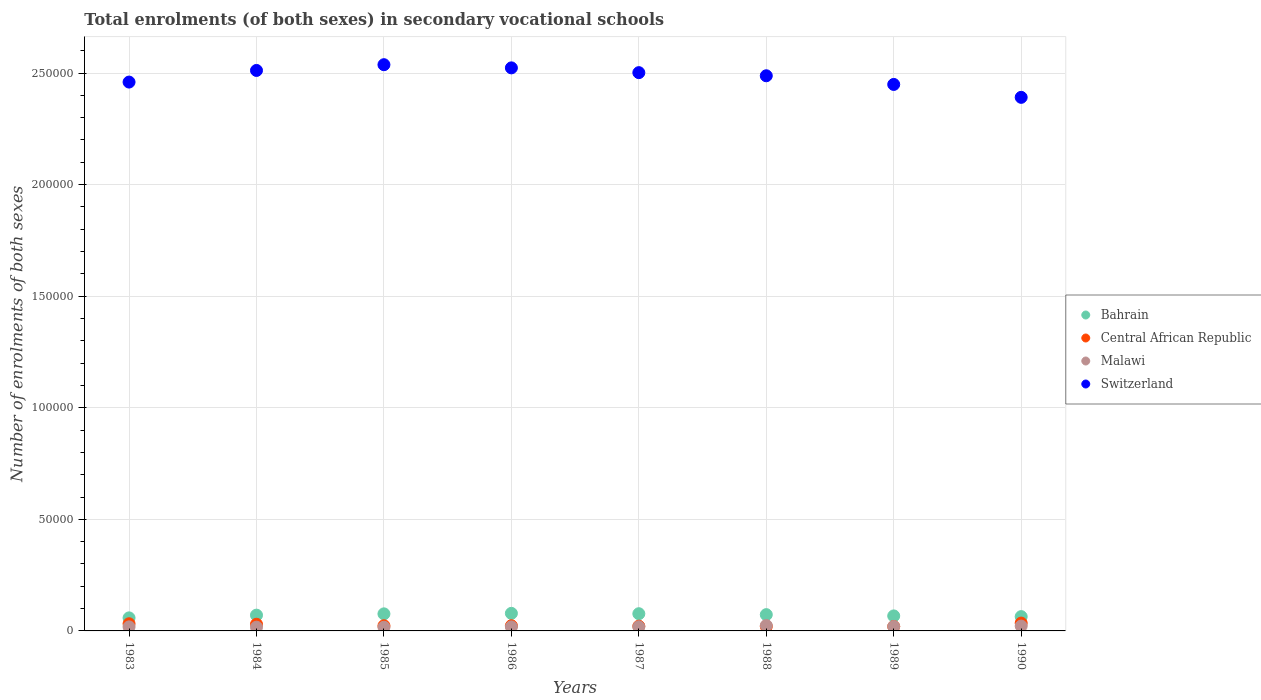How many different coloured dotlines are there?
Offer a very short reply. 4. What is the number of enrolments in secondary schools in Central African Republic in 1990?
Ensure brevity in your answer.  3514. Across all years, what is the maximum number of enrolments in secondary schools in Malawi?
Ensure brevity in your answer.  2427. Across all years, what is the minimum number of enrolments in secondary schools in Malawi?
Offer a terse response. 1669. In which year was the number of enrolments in secondary schools in Central African Republic maximum?
Keep it short and to the point. 1990. What is the total number of enrolments in secondary schools in Switzerland in the graph?
Keep it short and to the point. 1.99e+06. What is the difference between the number of enrolments in secondary schools in Bahrain in 1986 and that in 1987?
Your answer should be compact. 160. What is the difference between the number of enrolments in secondary schools in Bahrain in 1989 and the number of enrolments in secondary schools in Switzerland in 1983?
Offer a very short reply. -2.39e+05. What is the average number of enrolments in secondary schools in Central African Republic per year?
Your answer should be very brief. 2562.25. In the year 1985, what is the difference between the number of enrolments in secondary schools in Central African Republic and number of enrolments in secondary schools in Malawi?
Your answer should be very brief. 648. What is the ratio of the number of enrolments in secondary schools in Bahrain in 1984 to that in 1986?
Give a very brief answer. 0.9. Is the difference between the number of enrolments in secondary schools in Central African Republic in 1987 and 1989 greater than the difference between the number of enrolments in secondary schools in Malawi in 1987 and 1989?
Offer a terse response. Yes. What is the difference between the highest and the second highest number of enrolments in secondary schools in Malawi?
Give a very brief answer. 251. What is the difference between the highest and the lowest number of enrolments in secondary schools in Malawi?
Your answer should be very brief. 758. Is it the case that in every year, the sum of the number of enrolments in secondary schools in Central African Republic and number of enrolments in secondary schools in Switzerland  is greater than the sum of number of enrolments in secondary schools in Malawi and number of enrolments in secondary schools in Bahrain?
Ensure brevity in your answer.  Yes. Is it the case that in every year, the sum of the number of enrolments in secondary schools in Switzerland and number of enrolments in secondary schools in Central African Republic  is greater than the number of enrolments in secondary schools in Bahrain?
Your answer should be compact. Yes. Is the number of enrolments in secondary schools in Bahrain strictly greater than the number of enrolments in secondary schools in Malawi over the years?
Provide a succinct answer. Yes. Is the number of enrolments in secondary schools in Bahrain strictly less than the number of enrolments in secondary schools in Malawi over the years?
Offer a terse response. No. What is the difference between two consecutive major ticks on the Y-axis?
Your response must be concise. 5.00e+04. Are the values on the major ticks of Y-axis written in scientific E-notation?
Keep it short and to the point. No. What is the title of the graph?
Keep it short and to the point. Total enrolments (of both sexes) in secondary vocational schools. What is the label or title of the Y-axis?
Your answer should be compact. Number of enrolments of both sexes. What is the Number of enrolments of both sexes in Bahrain in 1983?
Ensure brevity in your answer.  5844. What is the Number of enrolments of both sexes in Central African Republic in 1983?
Ensure brevity in your answer.  3213. What is the Number of enrolments of both sexes of Malawi in 1983?
Offer a very short reply. 1814. What is the Number of enrolments of both sexes in Switzerland in 1983?
Provide a succinct answer. 2.46e+05. What is the Number of enrolments of both sexes of Bahrain in 1984?
Your answer should be very brief. 7067. What is the Number of enrolments of both sexes in Central African Republic in 1984?
Your response must be concise. 2993. What is the Number of enrolments of both sexes of Malawi in 1984?
Your response must be concise. 1688. What is the Number of enrolments of both sexes in Switzerland in 1984?
Ensure brevity in your answer.  2.51e+05. What is the Number of enrolments of both sexes in Bahrain in 1985?
Keep it short and to the point. 7648. What is the Number of enrolments of both sexes of Central African Republic in 1985?
Provide a succinct answer. 2317. What is the Number of enrolments of both sexes in Malawi in 1985?
Your answer should be very brief. 1669. What is the Number of enrolments of both sexes in Switzerland in 1985?
Give a very brief answer. 2.54e+05. What is the Number of enrolments of both sexes in Bahrain in 1986?
Ensure brevity in your answer.  7870. What is the Number of enrolments of both sexes in Central African Republic in 1986?
Offer a terse response. 2332. What is the Number of enrolments of both sexes of Malawi in 1986?
Your response must be concise. 1818. What is the Number of enrolments of both sexes in Switzerland in 1986?
Your answer should be very brief. 2.52e+05. What is the Number of enrolments of both sexes of Bahrain in 1987?
Offer a very short reply. 7710. What is the Number of enrolments of both sexes in Central African Republic in 1987?
Offer a very short reply. 2132. What is the Number of enrolments of both sexes in Malawi in 1987?
Your answer should be compact. 1860. What is the Number of enrolments of both sexes in Switzerland in 1987?
Offer a very short reply. 2.50e+05. What is the Number of enrolments of both sexes of Bahrain in 1988?
Offer a terse response. 7294. What is the Number of enrolments of both sexes of Central African Republic in 1988?
Give a very brief answer. 2008. What is the Number of enrolments of both sexes in Malawi in 1988?
Provide a succinct answer. 2427. What is the Number of enrolments of both sexes in Switzerland in 1988?
Your response must be concise. 2.49e+05. What is the Number of enrolments of both sexes of Bahrain in 1989?
Your answer should be compact. 6725. What is the Number of enrolments of both sexes in Central African Republic in 1989?
Keep it short and to the point. 1989. What is the Number of enrolments of both sexes of Malawi in 1989?
Your response must be concise. 1984. What is the Number of enrolments of both sexes in Switzerland in 1989?
Offer a very short reply. 2.45e+05. What is the Number of enrolments of both sexes of Bahrain in 1990?
Your response must be concise. 6412. What is the Number of enrolments of both sexes of Central African Republic in 1990?
Your response must be concise. 3514. What is the Number of enrolments of both sexes of Malawi in 1990?
Your response must be concise. 2176. What is the Number of enrolments of both sexes of Switzerland in 1990?
Provide a succinct answer. 2.39e+05. Across all years, what is the maximum Number of enrolments of both sexes of Bahrain?
Offer a terse response. 7870. Across all years, what is the maximum Number of enrolments of both sexes of Central African Republic?
Offer a terse response. 3514. Across all years, what is the maximum Number of enrolments of both sexes in Malawi?
Your response must be concise. 2427. Across all years, what is the maximum Number of enrolments of both sexes of Switzerland?
Provide a succinct answer. 2.54e+05. Across all years, what is the minimum Number of enrolments of both sexes of Bahrain?
Your answer should be compact. 5844. Across all years, what is the minimum Number of enrolments of both sexes in Central African Republic?
Your answer should be compact. 1989. Across all years, what is the minimum Number of enrolments of both sexes in Malawi?
Your response must be concise. 1669. Across all years, what is the minimum Number of enrolments of both sexes in Switzerland?
Offer a very short reply. 2.39e+05. What is the total Number of enrolments of both sexes of Bahrain in the graph?
Offer a terse response. 5.66e+04. What is the total Number of enrolments of both sexes in Central African Republic in the graph?
Offer a terse response. 2.05e+04. What is the total Number of enrolments of both sexes of Malawi in the graph?
Provide a short and direct response. 1.54e+04. What is the total Number of enrolments of both sexes of Switzerland in the graph?
Offer a very short reply. 1.99e+06. What is the difference between the Number of enrolments of both sexes in Bahrain in 1983 and that in 1984?
Keep it short and to the point. -1223. What is the difference between the Number of enrolments of both sexes of Central African Republic in 1983 and that in 1984?
Offer a very short reply. 220. What is the difference between the Number of enrolments of both sexes in Malawi in 1983 and that in 1984?
Offer a very short reply. 126. What is the difference between the Number of enrolments of both sexes of Switzerland in 1983 and that in 1984?
Keep it short and to the point. -5213. What is the difference between the Number of enrolments of both sexes in Bahrain in 1983 and that in 1985?
Provide a succinct answer. -1804. What is the difference between the Number of enrolments of both sexes of Central African Republic in 1983 and that in 1985?
Make the answer very short. 896. What is the difference between the Number of enrolments of both sexes in Malawi in 1983 and that in 1985?
Provide a short and direct response. 145. What is the difference between the Number of enrolments of both sexes of Switzerland in 1983 and that in 1985?
Offer a very short reply. -7787. What is the difference between the Number of enrolments of both sexes of Bahrain in 1983 and that in 1986?
Keep it short and to the point. -2026. What is the difference between the Number of enrolments of both sexes of Central African Republic in 1983 and that in 1986?
Offer a very short reply. 881. What is the difference between the Number of enrolments of both sexes in Malawi in 1983 and that in 1986?
Make the answer very short. -4. What is the difference between the Number of enrolments of both sexes of Switzerland in 1983 and that in 1986?
Offer a very short reply. -6367. What is the difference between the Number of enrolments of both sexes in Bahrain in 1983 and that in 1987?
Ensure brevity in your answer.  -1866. What is the difference between the Number of enrolments of both sexes of Central African Republic in 1983 and that in 1987?
Give a very brief answer. 1081. What is the difference between the Number of enrolments of both sexes of Malawi in 1983 and that in 1987?
Keep it short and to the point. -46. What is the difference between the Number of enrolments of both sexes of Switzerland in 1983 and that in 1987?
Ensure brevity in your answer.  -4228. What is the difference between the Number of enrolments of both sexes in Bahrain in 1983 and that in 1988?
Give a very brief answer. -1450. What is the difference between the Number of enrolments of both sexes of Central African Republic in 1983 and that in 1988?
Your answer should be very brief. 1205. What is the difference between the Number of enrolments of both sexes in Malawi in 1983 and that in 1988?
Keep it short and to the point. -613. What is the difference between the Number of enrolments of both sexes of Switzerland in 1983 and that in 1988?
Offer a very short reply. -2825. What is the difference between the Number of enrolments of both sexes of Bahrain in 1983 and that in 1989?
Provide a short and direct response. -881. What is the difference between the Number of enrolments of both sexes in Central African Republic in 1983 and that in 1989?
Offer a terse response. 1224. What is the difference between the Number of enrolments of both sexes of Malawi in 1983 and that in 1989?
Make the answer very short. -170. What is the difference between the Number of enrolments of both sexes in Switzerland in 1983 and that in 1989?
Provide a short and direct response. 1058. What is the difference between the Number of enrolments of both sexes of Bahrain in 1983 and that in 1990?
Give a very brief answer. -568. What is the difference between the Number of enrolments of both sexes of Central African Republic in 1983 and that in 1990?
Provide a short and direct response. -301. What is the difference between the Number of enrolments of both sexes of Malawi in 1983 and that in 1990?
Your response must be concise. -362. What is the difference between the Number of enrolments of both sexes of Switzerland in 1983 and that in 1990?
Your answer should be compact. 6842. What is the difference between the Number of enrolments of both sexes in Bahrain in 1984 and that in 1985?
Offer a very short reply. -581. What is the difference between the Number of enrolments of both sexes of Central African Republic in 1984 and that in 1985?
Provide a short and direct response. 676. What is the difference between the Number of enrolments of both sexes in Switzerland in 1984 and that in 1985?
Make the answer very short. -2574. What is the difference between the Number of enrolments of both sexes of Bahrain in 1984 and that in 1986?
Your response must be concise. -803. What is the difference between the Number of enrolments of both sexes in Central African Republic in 1984 and that in 1986?
Provide a short and direct response. 661. What is the difference between the Number of enrolments of both sexes in Malawi in 1984 and that in 1986?
Provide a short and direct response. -130. What is the difference between the Number of enrolments of both sexes of Switzerland in 1984 and that in 1986?
Provide a short and direct response. -1154. What is the difference between the Number of enrolments of both sexes in Bahrain in 1984 and that in 1987?
Your answer should be very brief. -643. What is the difference between the Number of enrolments of both sexes of Central African Republic in 1984 and that in 1987?
Provide a short and direct response. 861. What is the difference between the Number of enrolments of both sexes in Malawi in 1984 and that in 1987?
Keep it short and to the point. -172. What is the difference between the Number of enrolments of both sexes in Switzerland in 1984 and that in 1987?
Your answer should be compact. 985. What is the difference between the Number of enrolments of both sexes of Bahrain in 1984 and that in 1988?
Give a very brief answer. -227. What is the difference between the Number of enrolments of both sexes in Central African Republic in 1984 and that in 1988?
Provide a succinct answer. 985. What is the difference between the Number of enrolments of both sexes of Malawi in 1984 and that in 1988?
Ensure brevity in your answer.  -739. What is the difference between the Number of enrolments of both sexes in Switzerland in 1984 and that in 1988?
Offer a very short reply. 2388. What is the difference between the Number of enrolments of both sexes of Bahrain in 1984 and that in 1989?
Give a very brief answer. 342. What is the difference between the Number of enrolments of both sexes in Central African Republic in 1984 and that in 1989?
Provide a short and direct response. 1004. What is the difference between the Number of enrolments of both sexes in Malawi in 1984 and that in 1989?
Your answer should be compact. -296. What is the difference between the Number of enrolments of both sexes of Switzerland in 1984 and that in 1989?
Provide a succinct answer. 6271. What is the difference between the Number of enrolments of both sexes of Bahrain in 1984 and that in 1990?
Your answer should be compact. 655. What is the difference between the Number of enrolments of both sexes of Central African Republic in 1984 and that in 1990?
Provide a short and direct response. -521. What is the difference between the Number of enrolments of both sexes in Malawi in 1984 and that in 1990?
Offer a very short reply. -488. What is the difference between the Number of enrolments of both sexes of Switzerland in 1984 and that in 1990?
Your answer should be very brief. 1.21e+04. What is the difference between the Number of enrolments of both sexes in Bahrain in 1985 and that in 1986?
Offer a very short reply. -222. What is the difference between the Number of enrolments of both sexes in Central African Republic in 1985 and that in 1986?
Your answer should be compact. -15. What is the difference between the Number of enrolments of both sexes in Malawi in 1985 and that in 1986?
Keep it short and to the point. -149. What is the difference between the Number of enrolments of both sexes in Switzerland in 1985 and that in 1986?
Keep it short and to the point. 1420. What is the difference between the Number of enrolments of both sexes of Bahrain in 1985 and that in 1987?
Your response must be concise. -62. What is the difference between the Number of enrolments of both sexes of Central African Republic in 1985 and that in 1987?
Give a very brief answer. 185. What is the difference between the Number of enrolments of both sexes in Malawi in 1985 and that in 1987?
Offer a terse response. -191. What is the difference between the Number of enrolments of both sexes in Switzerland in 1985 and that in 1987?
Make the answer very short. 3559. What is the difference between the Number of enrolments of both sexes of Bahrain in 1985 and that in 1988?
Your answer should be compact. 354. What is the difference between the Number of enrolments of both sexes in Central African Republic in 1985 and that in 1988?
Offer a terse response. 309. What is the difference between the Number of enrolments of both sexes of Malawi in 1985 and that in 1988?
Give a very brief answer. -758. What is the difference between the Number of enrolments of both sexes in Switzerland in 1985 and that in 1988?
Provide a short and direct response. 4962. What is the difference between the Number of enrolments of both sexes in Bahrain in 1985 and that in 1989?
Your answer should be compact. 923. What is the difference between the Number of enrolments of both sexes of Central African Republic in 1985 and that in 1989?
Give a very brief answer. 328. What is the difference between the Number of enrolments of both sexes of Malawi in 1985 and that in 1989?
Make the answer very short. -315. What is the difference between the Number of enrolments of both sexes of Switzerland in 1985 and that in 1989?
Ensure brevity in your answer.  8845. What is the difference between the Number of enrolments of both sexes of Bahrain in 1985 and that in 1990?
Provide a succinct answer. 1236. What is the difference between the Number of enrolments of both sexes of Central African Republic in 1985 and that in 1990?
Your response must be concise. -1197. What is the difference between the Number of enrolments of both sexes of Malawi in 1985 and that in 1990?
Your answer should be very brief. -507. What is the difference between the Number of enrolments of both sexes of Switzerland in 1985 and that in 1990?
Provide a succinct answer. 1.46e+04. What is the difference between the Number of enrolments of both sexes of Bahrain in 1986 and that in 1987?
Offer a very short reply. 160. What is the difference between the Number of enrolments of both sexes in Malawi in 1986 and that in 1987?
Provide a short and direct response. -42. What is the difference between the Number of enrolments of both sexes of Switzerland in 1986 and that in 1987?
Keep it short and to the point. 2139. What is the difference between the Number of enrolments of both sexes in Bahrain in 1986 and that in 1988?
Provide a succinct answer. 576. What is the difference between the Number of enrolments of both sexes in Central African Republic in 1986 and that in 1988?
Provide a short and direct response. 324. What is the difference between the Number of enrolments of both sexes of Malawi in 1986 and that in 1988?
Give a very brief answer. -609. What is the difference between the Number of enrolments of both sexes in Switzerland in 1986 and that in 1988?
Your answer should be very brief. 3542. What is the difference between the Number of enrolments of both sexes in Bahrain in 1986 and that in 1989?
Your answer should be compact. 1145. What is the difference between the Number of enrolments of both sexes in Central African Republic in 1986 and that in 1989?
Provide a short and direct response. 343. What is the difference between the Number of enrolments of both sexes of Malawi in 1986 and that in 1989?
Your answer should be very brief. -166. What is the difference between the Number of enrolments of both sexes in Switzerland in 1986 and that in 1989?
Make the answer very short. 7425. What is the difference between the Number of enrolments of both sexes in Bahrain in 1986 and that in 1990?
Offer a terse response. 1458. What is the difference between the Number of enrolments of both sexes of Central African Republic in 1986 and that in 1990?
Your response must be concise. -1182. What is the difference between the Number of enrolments of both sexes in Malawi in 1986 and that in 1990?
Your answer should be very brief. -358. What is the difference between the Number of enrolments of both sexes of Switzerland in 1986 and that in 1990?
Your answer should be very brief. 1.32e+04. What is the difference between the Number of enrolments of both sexes in Bahrain in 1987 and that in 1988?
Make the answer very short. 416. What is the difference between the Number of enrolments of both sexes of Central African Republic in 1987 and that in 1988?
Offer a very short reply. 124. What is the difference between the Number of enrolments of both sexes in Malawi in 1987 and that in 1988?
Give a very brief answer. -567. What is the difference between the Number of enrolments of both sexes in Switzerland in 1987 and that in 1988?
Give a very brief answer. 1403. What is the difference between the Number of enrolments of both sexes of Bahrain in 1987 and that in 1989?
Keep it short and to the point. 985. What is the difference between the Number of enrolments of both sexes of Central African Republic in 1987 and that in 1989?
Provide a succinct answer. 143. What is the difference between the Number of enrolments of both sexes in Malawi in 1987 and that in 1989?
Keep it short and to the point. -124. What is the difference between the Number of enrolments of both sexes of Switzerland in 1987 and that in 1989?
Your answer should be compact. 5286. What is the difference between the Number of enrolments of both sexes of Bahrain in 1987 and that in 1990?
Provide a short and direct response. 1298. What is the difference between the Number of enrolments of both sexes in Central African Republic in 1987 and that in 1990?
Your answer should be compact. -1382. What is the difference between the Number of enrolments of both sexes of Malawi in 1987 and that in 1990?
Give a very brief answer. -316. What is the difference between the Number of enrolments of both sexes of Switzerland in 1987 and that in 1990?
Ensure brevity in your answer.  1.11e+04. What is the difference between the Number of enrolments of both sexes in Bahrain in 1988 and that in 1989?
Keep it short and to the point. 569. What is the difference between the Number of enrolments of both sexes in Malawi in 1988 and that in 1989?
Offer a terse response. 443. What is the difference between the Number of enrolments of both sexes in Switzerland in 1988 and that in 1989?
Give a very brief answer. 3883. What is the difference between the Number of enrolments of both sexes in Bahrain in 1988 and that in 1990?
Ensure brevity in your answer.  882. What is the difference between the Number of enrolments of both sexes of Central African Republic in 1988 and that in 1990?
Give a very brief answer. -1506. What is the difference between the Number of enrolments of both sexes in Malawi in 1988 and that in 1990?
Provide a short and direct response. 251. What is the difference between the Number of enrolments of both sexes of Switzerland in 1988 and that in 1990?
Provide a succinct answer. 9667. What is the difference between the Number of enrolments of both sexes of Bahrain in 1989 and that in 1990?
Your answer should be compact. 313. What is the difference between the Number of enrolments of both sexes of Central African Republic in 1989 and that in 1990?
Your answer should be very brief. -1525. What is the difference between the Number of enrolments of both sexes in Malawi in 1989 and that in 1990?
Ensure brevity in your answer.  -192. What is the difference between the Number of enrolments of both sexes in Switzerland in 1989 and that in 1990?
Your response must be concise. 5784. What is the difference between the Number of enrolments of both sexes in Bahrain in 1983 and the Number of enrolments of both sexes in Central African Republic in 1984?
Your answer should be compact. 2851. What is the difference between the Number of enrolments of both sexes in Bahrain in 1983 and the Number of enrolments of both sexes in Malawi in 1984?
Provide a short and direct response. 4156. What is the difference between the Number of enrolments of both sexes of Bahrain in 1983 and the Number of enrolments of both sexes of Switzerland in 1984?
Keep it short and to the point. -2.45e+05. What is the difference between the Number of enrolments of both sexes in Central African Republic in 1983 and the Number of enrolments of both sexes in Malawi in 1984?
Your answer should be very brief. 1525. What is the difference between the Number of enrolments of both sexes in Central African Republic in 1983 and the Number of enrolments of both sexes in Switzerland in 1984?
Make the answer very short. -2.48e+05. What is the difference between the Number of enrolments of both sexes of Malawi in 1983 and the Number of enrolments of both sexes of Switzerland in 1984?
Your response must be concise. -2.49e+05. What is the difference between the Number of enrolments of both sexes of Bahrain in 1983 and the Number of enrolments of both sexes of Central African Republic in 1985?
Offer a terse response. 3527. What is the difference between the Number of enrolments of both sexes in Bahrain in 1983 and the Number of enrolments of both sexes in Malawi in 1985?
Provide a succinct answer. 4175. What is the difference between the Number of enrolments of both sexes in Bahrain in 1983 and the Number of enrolments of both sexes in Switzerland in 1985?
Provide a short and direct response. -2.48e+05. What is the difference between the Number of enrolments of both sexes of Central African Republic in 1983 and the Number of enrolments of both sexes of Malawi in 1985?
Offer a terse response. 1544. What is the difference between the Number of enrolments of both sexes of Central African Republic in 1983 and the Number of enrolments of both sexes of Switzerland in 1985?
Your response must be concise. -2.51e+05. What is the difference between the Number of enrolments of both sexes in Malawi in 1983 and the Number of enrolments of both sexes in Switzerland in 1985?
Provide a short and direct response. -2.52e+05. What is the difference between the Number of enrolments of both sexes in Bahrain in 1983 and the Number of enrolments of both sexes in Central African Republic in 1986?
Give a very brief answer. 3512. What is the difference between the Number of enrolments of both sexes in Bahrain in 1983 and the Number of enrolments of both sexes in Malawi in 1986?
Keep it short and to the point. 4026. What is the difference between the Number of enrolments of both sexes of Bahrain in 1983 and the Number of enrolments of both sexes of Switzerland in 1986?
Offer a terse response. -2.46e+05. What is the difference between the Number of enrolments of both sexes of Central African Republic in 1983 and the Number of enrolments of both sexes of Malawi in 1986?
Make the answer very short. 1395. What is the difference between the Number of enrolments of both sexes in Central African Republic in 1983 and the Number of enrolments of both sexes in Switzerland in 1986?
Give a very brief answer. -2.49e+05. What is the difference between the Number of enrolments of both sexes in Malawi in 1983 and the Number of enrolments of both sexes in Switzerland in 1986?
Give a very brief answer. -2.50e+05. What is the difference between the Number of enrolments of both sexes of Bahrain in 1983 and the Number of enrolments of both sexes of Central African Republic in 1987?
Provide a short and direct response. 3712. What is the difference between the Number of enrolments of both sexes in Bahrain in 1983 and the Number of enrolments of both sexes in Malawi in 1987?
Make the answer very short. 3984. What is the difference between the Number of enrolments of both sexes of Bahrain in 1983 and the Number of enrolments of both sexes of Switzerland in 1987?
Provide a short and direct response. -2.44e+05. What is the difference between the Number of enrolments of both sexes of Central African Republic in 1983 and the Number of enrolments of both sexes of Malawi in 1987?
Make the answer very short. 1353. What is the difference between the Number of enrolments of both sexes of Central African Republic in 1983 and the Number of enrolments of both sexes of Switzerland in 1987?
Keep it short and to the point. -2.47e+05. What is the difference between the Number of enrolments of both sexes in Malawi in 1983 and the Number of enrolments of both sexes in Switzerland in 1987?
Offer a terse response. -2.48e+05. What is the difference between the Number of enrolments of both sexes in Bahrain in 1983 and the Number of enrolments of both sexes in Central African Republic in 1988?
Keep it short and to the point. 3836. What is the difference between the Number of enrolments of both sexes of Bahrain in 1983 and the Number of enrolments of both sexes of Malawi in 1988?
Your response must be concise. 3417. What is the difference between the Number of enrolments of both sexes in Bahrain in 1983 and the Number of enrolments of both sexes in Switzerland in 1988?
Keep it short and to the point. -2.43e+05. What is the difference between the Number of enrolments of both sexes of Central African Republic in 1983 and the Number of enrolments of both sexes of Malawi in 1988?
Keep it short and to the point. 786. What is the difference between the Number of enrolments of both sexes of Central African Republic in 1983 and the Number of enrolments of both sexes of Switzerland in 1988?
Give a very brief answer. -2.46e+05. What is the difference between the Number of enrolments of both sexes of Malawi in 1983 and the Number of enrolments of both sexes of Switzerland in 1988?
Give a very brief answer. -2.47e+05. What is the difference between the Number of enrolments of both sexes of Bahrain in 1983 and the Number of enrolments of both sexes of Central African Republic in 1989?
Your answer should be compact. 3855. What is the difference between the Number of enrolments of both sexes in Bahrain in 1983 and the Number of enrolments of both sexes in Malawi in 1989?
Your answer should be very brief. 3860. What is the difference between the Number of enrolments of both sexes of Bahrain in 1983 and the Number of enrolments of both sexes of Switzerland in 1989?
Ensure brevity in your answer.  -2.39e+05. What is the difference between the Number of enrolments of both sexes of Central African Republic in 1983 and the Number of enrolments of both sexes of Malawi in 1989?
Offer a terse response. 1229. What is the difference between the Number of enrolments of both sexes in Central African Republic in 1983 and the Number of enrolments of both sexes in Switzerland in 1989?
Offer a terse response. -2.42e+05. What is the difference between the Number of enrolments of both sexes of Malawi in 1983 and the Number of enrolments of both sexes of Switzerland in 1989?
Provide a short and direct response. -2.43e+05. What is the difference between the Number of enrolments of both sexes in Bahrain in 1983 and the Number of enrolments of both sexes in Central African Republic in 1990?
Your response must be concise. 2330. What is the difference between the Number of enrolments of both sexes of Bahrain in 1983 and the Number of enrolments of both sexes of Malawi in 1990?
Your response must be concise. 3668. What is the difference between the Number of enrolments of both sexes in Bahrain in 1983 and the Number of enrolments of both sexes in Switzerland in 1990?
Offer a very short reply. -2.33e+05. What is the difference between the Number of enrolments of both sexes of Central African Republic in 1983 and the Number of enrolments of both sexes of Malawi in 1990?
Provide a short and direct response. 1037. What is the difference between the Number of enrolments of both sexes of Central African Republic in 1983 and the Number of enrolments of both sexes of Switzerland in 1990?
Ensure brevity in your answer.  -2.36e+05. What is the difference between the Number of enrolments of both sexes in Malawi in 1983 and the Number of enrolments of both sexes in Switzerland in 1990?
Provide a short and direct response. -2.37e+05. What is the difference between the Number of enrolments of both sexes of Bahrain in 1984 and the Number of enrolments of both sexes of Central African Republic in 1985?
Offer a terse response. 4750. What is the difference between the Number of enrolments of both sexes in Bahrain in 1984 and the Number of enrolments of both sexes in Malawi in 1985?
Ensure brevity in your answer.  5398. What is the difference between the Number of enrolments of both sexes in Bahrain in 1984 and the Number of enrolments of both sexes in Switzerland in 1985?
Offer a very short reply. -2.47e+05. What is the difference between the Number of enrolments of both sexes in Central African Republic in 1984 and the Number of enrolments of both sexes in Malawi in 1985?
Your answer should be very brief. 1324. What is the difference between the Number of enrolments of both sexes of Central African Republic in 1984 and the Number of enrolments of both sexes of Switzerland in 1985?
Ensure brevity in your answer.  -2.51e+05. What is the difference between the Number of enrolments of both sexes in Malawi in 1984 and the Number of enrolments of both sexes in Switzerland in 1985?
Offer a terse response. -2.52e+05. What is the difference between the Number of enrolments of both sexes of Bahrain in 1984 and the Number of enrolments of both sexes of Central African Republic in 1986?
Offer a terse response. 4735. What is the difference between the Number of enrolments of both sexes in Bahrain in 1984 and the Number of enrolments of both sexes in Malawi in 1986?
Provide a short and direct response. 5249. What is the difference between the Number of enrolments of both sexes of Bahrain in 1984 and the Number of enrolments of both sexes of Switzerland in 1986?
Offer a terse response. -2.45e+05. What is the difference between the Number of enrolments of both sexes in Central African Republic in 1984 and the Number of enrolments of both sexes in Malawi in 1986?
Your response must be concise. 1175. What is the difference between the Number of enrolments of both sexes in Central African Republic in 1984 and the Number of enrolments of both sexes in Switzerland in 1986?
Provide a succinct answer. -2.49e+05. What is the difference between the Number of enrolments of both sexes in Malawi in 1984 and the Number of enrolments of both sexes in Switzerland in 1986?
Provide a short and direct response. -2.51e+05. What is the difference between the Number of enrolments of both sexes of Bahrain in 1984 and the Number of enrolments of both sexes of Central African Republic in 1987?
Provide a succinct answer. 4935. What is the difference between the Number of enrolments of both sexes of Bahrain in 1984 and the Number of enrolments of both sexes of Malawi in 1987?
Keep it short and to the point. 5207. What is the difference between the Number of enrolments of both sexes of Bahrain in 1984 and the Number of enrolments of both sexes of Switzerland in 1987?
Your answer should be compact. -2.43e+05. What is the difference between the Number of enrolments of both sexes in Central African Republic in 1984 and the Number of enrolments of both sexes in Malawi in 1987?
Your answer should be compact. 1133. What is the difference between the Number of enrolments of both sexes in Central African Republic in 1984 and the Number of enrolments of both sexes in Switzerland in 1987?
Provide a short and direct response. -2.47e+05. What is the difference between the Number of enrolments of both sexes in Malawi in 1984 and the Number of enrolments of both sexes in Switzerland in 1987?
Offer a terse response. -2.48e+05. What is the difference between the Number of enrolments of both sexes of Bahrain in 1984 and the Number of enrolments of both sexes of Central African Republic in 1988?
Give a very brief answer. 5059. What is the difference between the Number of enrolments of both sexes in Bahrain in 1984 and the Number of enrolments of both sexes in Malawi in 1988?
Provide a short and direct response. 4640. What is the difference between the Number of enrolments of both sexes in Bahrain in 1984 and the Number of enrolments of both sexes in Switzerland in 1988?
Your response must be concise. -2.42e+05. What is the difference between the Number of enrolments of both sexes in Central African Republic in 1984 and the Number of enrolments of both sexes in Malawi in 1988?
Offer a very short reply. 566. What is the difference between the Number of enrolments of both sexes of Central African Republic in 1984 and the Number of enrolments of both sexes of Switzerland in 1988?
Provide a succinct answer. -2.46e+05. What is the difference between the Number of enrolments of both sexes of Malawi in 1984 and the Number of enrolments of both sexes of Switzerland in 1988?
Give a very brief answer. -2.47e+05. What is the difference between the Number of enrolments of both sexes in Bahrain in 1984 and the Number of enrolments of both sexes in Central African Republic in 1989?
Provide a succinct answer. 5078. What is the difference between the Number of enrolments of both sexes of Bahrain in 1984 and the Number of enrolments of both sexes of Malawi in 1989?
Provide a succinct answer. 5083. What is the difference between the Number of enrolments of both sexes in Bahrain in 1984 and the Number of enrolments of both sexes in Switzerland in 1989?
Your response must be concise. -2.38e+05. What is the difference between the Number of enrolments of both sexes in Central African Republic in 1984 and the Number of enrolments of both sexes in Malawi in 1989?
Keep it short and to the point. 1009. What is the difference between the Number of enrolments of both sexes in Central African Republic in 1984 and the Number of enrolments of both sexes in Switzerland in 1989?
Offer a terse response. -2.42e+05. What is the difference between the Number of enrolments of both sexes in Malawi in 1984 and the Number of enrolments of both sexes in Switzerland in 1989?
Ensure brevity in your answer.  -2.43e+05. What is the difference between the Number of enrolments of both sexes of Bahrain in 1984 and the Number of enrolments of both sexes of Central African Republic in 1990?
Your response must be concise. 3553. What is the difference between the Number of enrolments of both sexes of Bahrain in 1984 and the Number of enrolments of both sexes of Malawi in 1990?
Make the answer very short. 4891. What is the difference between the Number of enrolments of both sexes in Bahrain in 1984 and the Number of enrolments of both sexes in Switzerland in 1990?
Keep it short and to the point. -2.32e+05. What is the difference between the Number of enrolments of both sexes in Central African Republic in 1984 and the Number of enrolments of both sexes in Malawi in 1990?
Ensure brevity in your answer.  817. What is the difference between the Number of enrolments of both sexes in Central African Republic in 1984 and the Number of enrolments of both sexes in Switzerland in 1990?
Your answer should be compact. -2.36e+05. What is the difference between the Number of enrolments of both sexes of Malawi in 1984 and the Number of enrolments of both sexes of Switzerland in 1990?
Ensure brevity in your answer.  -2.37e+05. What is the difference between the Number of enrolments of both sexes in Bahrain in 1985 and the Number of enrolments of both sexes in Central African Republic in 1986?
Make the answer very short. 5316. What is the difference between the Number of enrolments of both sexes of Bahrain in 1985 and the Number of enrolments of both sexes of Malawi in 1986?
Offer a terse response. 5830. What is the difference between the Number of enrolments of both sexes of Bahrain in 1985 and the Number of enrolments of both sexes of Switzerland in 1986?
Your answer should be very brief. -2.45e+05. What is the difference between the Number of enrolments of both sexes in Central African Republic in 1985 and the Number of enrolments of both sexes in Malawi in 1986?
Keep it short and to the point. 499. What is the difference between the Number of enrolments of both sexes of Central African Republic in 1985 and the Number of enrolments of both sexes of Switzerland in 1986?
Give a very brief answer. -2.50e+05. What is the difference between the Number of enrolments of both sexes in Malawi in 1985 and the Number of enrolments of both sexes in Switzerland in 1986?
Ensure brevity in your answer.  -2.51e+05. What is the difference between the Number of enrolments of both sexes of Bahrain in 1985 and the Number of enrolments of both sexes of Central African Republic in 1987?
Provide a succinct answer. 5516. What is the difference between the Number of enrolments of both sexes of Bahrain in 1985 and the Number of enrolments of both sexes of Malawi in 1987?
Give a very brief answer. 5788. What is the difference between the Number of enrolments of both sexes of Bahrain in 1985 and the Number of enrolments of both sexes of Switzerland in 1987?
Provide a short and direct response. -2.43e+05. What is the difference between the Number of enrolments of both sexes of Central African Republic in 1985 and the Number of enrolments of both sexes of Malawi in 1987?
Offer a terse response. 457. What is the difference between the Number of enrolments of both sexes in Central African Republic in 1985 and the Number of enrolments of both sexes in Switzerland in 1987?
Give a very brief answer. -2.48e+05. What is the difference between the Number of enrolments of both sexes of Malawi in 1985 and the Number of enrolments of both sexes of Switzerland in 1987?
Provide a succinct answer. -2.48e+05. What is the difference between the Number of enrolments of both sexes in Bahrain in 1985 and the Number of enrolments of both sexes in Central African Republic in 1988?
Ensure brevity in your answer.  5640. What is the difference between the Number of enrolments of both sexes in Bahrain in 1985 and the Number of enrolments of both sexes in Malawi in 1988?
Your answer should be compact. 5221. What is the difference between the Number of enrolments of both sexes in Bahrain in 1985 and the Number of enrolments of both sexes in Switzerland in 1988?
Provide a short and direct response. -2.41e+05. What is the difference between the Number of enrolments of both sexes in Central African Republic in 1985 and the Number of enrolments of both sexes in Malawi in 1988?
Offer a terse response. -110. What is the difference between the Number of enrolments of both sexes of Central African Republic in 1985 and the Number of enrolments of both sexes of Switzerland in 1988?
Make the answer very short. -2.46e+05. What is the difference between the Number of enrolments of both sexes in Malawi in 1985 and the Number of enrolments of both sexes in Switzerland in 1988?
Your response must be concise. -2.47e+05. What is the difference between the Number of enrolments of both sexes in Bahrain in 1985 and the Number of enrolments of both sexes in Central African Republic in 1989?
Your answer should be very brief. 5659. What is the difference between the Number of enrolments of both sexes in Bahrain in 1985 and the Number of enrolments of both sexes in Malawi in 1989?
Your answer should be compact. 5664. What is the difference between the Number of enrolments of both sexes of Bahrain in 1985 and the Number of enrolments of both sexes of Switzerland in 1989?
Provide a short and direct response. -2.37e+05. What is the difference between the Number of enrolments of both sexes in Central African Republic in 1985 and the Number of enrolments of both sexes in Malawi in 1989?
Provide a short and direct response. 333. What is the difference between the Number of enrolments of both sexes of Central African Republic in 1985 and the Number of enrolments of both sexes of Switzerland in 1989?
Provide a short and direct response. -2.43e+05. What is the difference between the Number of enrolments of both sexes of Malawi in 1985 and the Number of enrolments of both sexes of Switzerland in 1989?
Ensure brevity in your answer.  -2.43e+05. What is the difference between the Number of enrolments of both sexes in Bahrain in 1985 and the Number of enrolments of both sexes in Central African Republic in 1990?
Your response must be concise. 4134. What is the difference between the Number of enrolments of both sexes of Bahrain in 1985 and the Number of enrolments of both sexes of Malawi in 1990?
Provide a succinct answer. 5472. What is the difference between the Number of enrolments of both sexes in Bahrain in 1985 and the Number of enrolments of both sexes in Switzerland in 1990?
Keep it short and to the point. -2.31e+05. What is the difference between the Number of enrolments of both sexes in Central African Republic in 1985 and the Number of enrolments of both sexes in Malawi in 1990?
Offer a very short reply. 141. What is the difference between the Number of enrolments of both sexes of Central African Republic in 1985 and the Number of enrolments of both sexes of Switzerland in 1990?
Your response must be concise. -2.37e+05. What is the difference between the Number of enrolments of both sexes of Malawi in 1985 and the Number of enrolments of both sexes of Switzerland in 1990?
Offer a terse response. -2.37e+05. What is the difference between the Number of enrolments of both sexes in Bahrain in 1986 and the Number of enrolments of both sexes in Central African Republic in 1987?
Your response must be concise. 5738. What is the difference between the Number of enrolments of both sexes in Bahrain in 1986 and the Number of enrolments of both sexes in Malawi in 1987?
Give a very brief answer. 6010. What is the difference between the Number of enrolments of both sexes of Bahrain in 1986 and the Number of enrolments of both sexes of Switzerland in 1987?
Offer a very short reply. -2.42e+05. What is the difference between the Number of enrolments of both sexes of Central African Republic in 1986 and the Number of enrolments of both sexes of Malawi in 1987?
Make the answer very short. 472. What is the difference between the Number of enrolments of both sexes of Central African Republic in 1986 and the Number of enrolments of both sexes of Switzerland in 1987?
Your answer should be compact. -2.48e+05. What is the difference between the Number of enrolments of both sexes in Malawi in 1986 and the Number of enrolments of both sexes in Switzerland in 1987?
Provide a short and direct response. -2.48e+05. What is the difference between the Number of enrolments of both sexes of Bahrain in 1986 and the Number of enrolments of both sexes of Central African Republic in 1988?
Your response must be concise. 5862. What is the difference between the Number of enrolments of both sexes in Bahrain in 1986 and the Number of enrolments of both sexes in Malawi in 1988?
Keep it short and to the point. 5443. What is the difference between the Number of enrolments of both sexes in Bahrain in 1986 and the Number of enrolments of both sexes in Switzerland in 1988?
Offer a terse response. -2.41e+05. What is the difference between the Number of enrolments of both sexes of Central African Republic in 1986 and the Number of enrolments of both sexes of Malawi in 1988?
Provide a short and direct response. -95. What is the difference between the Number of enrolments of both sexes in Central African Republic in 1986 and the Number of enrolments of both sexes in Switzerland in 1988?
Offer a terse response. -2.46e+05. What is the difference between the Number of enrolments of both sexes in Malawi in 1986 and the Number of enrolments of both sexes in Switzerland in 1988?
Provide a short and direct response. -2.47e+05. What is the difference between the Number of enrolments of both sexes in Bahrain in 1986 and the Number of enrolments of both sexes in Central African Republic in 1989?
Offer a very short reply. 5881. What is the difference between the Number of enrolments of both sexes of Bahrain in 1986 and the Number of enrolments of both sexes of Malawi in 1989?
Offer a very short reply. 5886. What is the difference between the Number of enrolments of both sexes in Bahrain in 1986 and the Number of enrolments of both sexes in Switzerland in 1989?
Give a very brief answer. -2.37e+05. What is the difference between the Number of enrolments of both sexes of Central African Republic in 1986 and the Number of enrolments of both sexes of Malawi in 1989?
Give a very brief answer. 348. What is the difference between the Number of enrolments of both sexes in Central African Republic in 1986 and the Number of enrolments of both sexes in Switzerland in 1989?
Provide a succinct answer. -2.43e+05. What is the difference between the Number of enrolments of both sexes in Malawi in 1986 and the Number of enrolments of both sexes in Switzerland in 1989?
Offer a terse response. -2.43e+05. What is the difference between the Number of enrolments of both sexes of Bahrain in 1986 and the Number of enrolments of both sexes of Central African Republic in 1990?
Offer a very short reply. 4356. What is the difference between the Number of enrolments of both sexes of Bahrain in 1986 and the Number of enrolments of both sexes of Malawi in 1990?
Provide a succinct answer. 5694. What is the difference between the Number of enrolments of both sexes of Bahrain in 1986 and the Number of enrolments of both sexes of Switzerland in 1990?
Offer a very short reply. -2.31e+05. What is the difference between the Number of enrolments of both sexes of Central African Republic in 1986 and the Number of enrolments of both sexes of Malawi in 1990?
Keep it short and to the point. 156. What is the difference between the Number of enrolments of both sexes in Central African Republic in 1986 and the Number of enrolments of both sexes in Switzerland in 1990?
Give a very brief answer. -2.37e+05. What is the difference between the Number of enrolments of both sexes in Malawi in 1986 and the Number of enrolments of both sexes in Switzerland in 1990?
Provide a short and direct response. -2.37e+05. What is the difference between the Number of enrolments of both sexes of Bahrain in 1987 and the Number of enrolments of both sexes of Central African Republic in 1988?
Offer a very short reply. 5702. What is the difference between the Number of enrolments of both sexes of Bahrain in 1987 and the Number of enrolments of both sexes of Malawi in 1988?
Make the answer very short. 5283. What is the difference between the Number of enrolments of both sexes of Bahrain in 1987 and the Number of enrolments of both sexes of Switzerland in 1988?
Your answer should be very brief. -2.41e+05. What is the difference between the Number of enrolments of both sexes of Central African Republic in 1987 and the Number of enrolments of both sexes of Malawi in 1988?
Your answer should be compact. -295. What is the difference between the Number of enrolments of both sexes of Central African Republic in 1987 and the Number of enrolments of both sexes of Switzerland in 1988?
Offer a very short reply. -2.47e+05. What is the difference between the Number of enrolments of both sexes in Malawi in 1987 and the Number of enrolments of both sexes in Switzerland in 1988?
Provide a succinct answer. -2.47e+05. What is the difference between the Number of enrolments of both sexes of Bahrain in 1987 and the Number of enrolments of both sexes of Central African Republic in 1989?
Provide a succinct answer. 5721. What is the difference between the Number of enrolments of both sexes in Bahrain in 1987 and the Number of enrolments of both sexes in Malawi in 1989?
Offer a terse response. 5726. What is the difference between the Number of enrolments of both sexes of Bahrain in 1987 and the Number of enrolments of both sexes of Switzerland in 1989?
Provide a succinct answer. -2.37e+05. What is the difference between the Number of enrolments of both sexes of Central African Republic in 1987 and the Number of enrolments of both sexes of Malawi in 1989?
Offer a very short reply. 148. What is the difference between the Number of enrolments of both sexes in Central African Republic in 1987 and the Number of enrolments of both sexes in Switzerland in 1989?
Keep it short and to the point. -2.43e+05. What is the difference between the Number of enrolments of both sexes of Malawi in 1987 and the Number of enrolments of both sexes of Switzerland in 1989?
Your response must be concise. -2.43e+05. What is the difference between the Number of enrolments of both sexes in Bahrain in 1987 and the Number of enrolments of both sexes in Central African Republic in 1990?
Offer a very short reply. 4196. What is the difference between the Number of enrolments of both sexes in Bahrain in 1987 and the Number of enrolments of both sexes in Malawi in 1990?
Make the answer very short. 5534. What is the difference between the Number of enrolments of both sexes in Bahrain in 1987 and the Number of enrolments of both sexes in Switzerland in 1990?
Keep it short and to the point. -2.31e+05. What is the difference between the Number of enrolments of both sexes in Central African Republic in 1987 and the Number of enrolments of both sexes in Malawi in 1990?
Provide a short and direct response. -44. What is the difference between the Number of enrolments of both sexes in Central African Republic in 1987 and the Number of enrolments of both sexes in Switzerland in 1990?
Your response must be concise. -2.37e+05. What is the difference between the Number of enrolments of both sexes of Malawi in 1987 and the Number of enrolments of both sexes of Switzerland in 1990?
Your response must be concise. -2.37e+05. What is the difference between the Number of enrolments of both sexes in Bahrain in 1988 and the Number of enrolments of both sexes in Central African Republic in 1989?
Provide a succinct answer. 5305. What is the difference between the Number of enrolments of both sexes of Bahrain in 1988 and the Number of enrolments of both sexes of Malawi in 1989?
Your answer should be very brief. 5310. What is the difference between the Number of enrolments of both sexes in Bahrain in 1988 and the Number of enrolments of both sexes in Switzerland in 1989?
Your answer should be compact. -2.38e+05. What is the difference between the Number of enrolments of both sexes in Central African Republic in 1988 and the Number of enrolments of both sexes in Switzerland in 1989?
Provide a short and direct response. -2.43e+05. What is the difference between the Number of enrolments of both sexes in Malawi in 1988 and the Number of enrolments of both sexes in Switzerland in 1989?
Keep it short and to the point. -2.42e+05. What is the difference between the Number of enrolments of both sexes of Bahrain in 1988 and the Number of enrolments of both sexes of Central African Republic in 1990?
Your response must be concise. 3780. What is the difference between the Number of enrolments of both sexes in Bahrain in 1988 and the Number of enrolments of both sexes in Malawi in 1990?
Keep it short and to the point. 5118. What is the difference between the Number of enrolments of both sexes in Bahrain in 1988 and the Number of enrolments of both sexes in Switzerland in 1990?
Your response must be concise. -2.32e+05. What is the difference between the Number of enrolments of both sexes in Central African Republic in 1988 and the Number of enrolments of both sexes in Malawi in 1990?
Your response must be concise. -168. What is the difference between the Number of enrolments of both sexes in Central African Republic in 1988 and the Number of enrolments of both sexes in Switzerland in 1990?
Your answer should be compact. -2.37e+05. What is the difference between the Number of enrolments of both sexes in Malawi in 1988 and the Number of enrolments of both sexes in Switzerland in 1990?
Your response must be concise. -2.37e+05. What is the difference between the Number of enrolments of both sexes in Bahrain in 1989 and the Number of enrolments of both sexes in Central African Republic in 1990?
Make the answer very short. 3211. What is the difference between the Number of enrolments of both sexes in Bahrain in 1989 and the Number of enrolments of both sexes in Malawi in 1990?
Make the answer very short. 4549. What is the difference between the Number of enrolments of both sexes of Bahrain in 1989 and the Number of enrolments of both sexes of Switzerland in 1990?
Provide a succinct answer. -2.32e+05. What is the difference between the Number of enrolments of both sexes in Central African Republic in 1989 and the Number of enrolments of both sexes in Malawi in 1990?
Ensure brevity in your answer.  -187. What is the difference between the Number of enrolments of both sexes in Central African Republic in 1989 and the Number of enrolments of both sexes in Switzerland in 1990?
Offer a very short reply. -2.37e+05. What is the difference between the Number of enrolments of both sexes of Malawi in 1989 and the Number of enrolments of both sexes of Switzerland in 1990?
Your answer should be very brief. -2.37e+05. What is the average Number of enrolments of both sexes of Bahrain per year?
Offer a terse response. 7071.25. What is the average Number of enrolments of both sexes in Central African Republic per year?
Your response must be concise. 2562.25. What is the average Number of enrolments of both sexes in Malawi per year?
Offer a terse response. 1929.5. What is the average Number of enrolments of both sexes in Switzerland per year?
Ensure brevity in your answer.  2.48e+05. In the year 1983, what is the difference between the Number of enrolments of both sexes of Bahrain and Number of enrolments of both sexes of Central African Republic?
Offer a very short reply. 2631. In the year 1983, what is the difference between the Number of enrolments of both sexes in Bahrain and Number of enrolments of both sexes in Malawi?
Offer a very short reply. 4030. In the year 1983, what is the difference between the Number of enrolments of both sexes in Bahrain and Number of enrolments of both sexes in Switzerland?
Ensure brevity in your answer.  -2.40e+05. In the year 1983, what is the difference between the Number of enrolments of both sexes of Central African Republic and Number of enrolments of both sexes of Malawi?
Your answer should be very brief. 1399. In the year 1983, what is the difference between the Number of enrolments of both sexes of Central African Republic and Number of enrolments of both sexes of Switzerland?
Provide a succinct answer. -2.43e+05. In the year 1983, what is the difference between the Number of enrolments of both sexes in Malawi and Number of enrolments of both sexes in Switzerland?
Give a very brief answer. -2.44e+05. In the year 1984, what is the difference between the Number of enrolments of both sexes in Bahrain and Number of enrolments of both sexes in Central African Republic?
Give a very brief answer. 4074. In the year 1984, what is the difference between the Number of enrolments of both sexes of Bahrain and Number of enrolments of both sexes of Malawi?
Give a very brief answer. 5379. In the year 1984, what is the difference between the Number of enrolments of both sexes in Bahrain and Number of enrolments of both sexes in Switzerland?
Offer a terse response. -2.44e+05. In the year 1984, what is the difference between the Number of enrolments of both sexes in Central African Republic and Number of enrolments of both sexes in Malawi?
Ensure brevity in your answer.  1305. In the year 1984, what is the difference between the Number of enrolments of both sexes of Central African Republic and Number of enrolments of both sexes of Switzerland?
Ensure brevity in your answer.  -2.48e+05. In the year 1984, what is the difference between the Number of enrolments of both sexes of Malawi and Number of enrolments of both sexes of Switzerland?
Give a very brief answer. -2.49e+05. In the year 1985, what is the difference between the Number of enrolments of both sexes of Bahrain and Number of enrolments of both sexes of Central African Republic?
Ensure brevity in your answer.  5331. In the year 1985, what is the difference between the Number of enrolments of both sexes of Bahrain and Number of enrolments of both sexes of Malawi?
Offer a very short reply. 5979. In the year 1985, what is the difference between the Number of enrolments of both sexes of Bahrain and Number of enrolments of both sexes of Switzerland?
Offer a terse response. -2.46e+05. In the year 1985, what is the difference between the Number of enrolments of both sexes of Central African Republic and Number of enrolments of both sexes of Malawi?
Make the answer very short. 648. In the year 1985, what is the difference between the Number of enrolments of both sexes in Central African Republic and Number of enrolments of both sexes in Switzerland?
Your answer should be very brief. -2.51e+05. In the year 1985, what is the difference between the Number of enrolments of both sexes of Malawi and Number of enrolments of both sexes of Switzerland?
Your answer should be compact. -2.52e+05. In the year 1986, what is the difference between the Number of enrolments of both sexes in Bahrain and Number of enrolments of both sexes in Central African Republic?
Make the answer very short. 5538. In the year 1986, what is the difference between the Number of enrolments of both sexes of Bahrain and Number of enrolments of both sexes of Malawi?
Keep it short and to the point. 6052. In the year 1986, what is the difference between the Number of enrolments of both sexes of Bahrain and Number of enrolments of both sexes of Switzerland?
Keep it short and to the point. -2.44e+05. In the year 1986, what is the difference between the Number of enrolments of both sexes in Central African Republic and Number of enrolments of both sexes in Malawi?
Keep it short and to the point. 514. In the year 1986, what is the difference between the Number of enrolments of both sexes of Central African Republic and Number of enrolments of both sexes of Switzerland?
Your response must be concise. -2.50e+05. In the year 1986, what is the difference between the Number of enrolments of both sexes of Malawi and Number of enrolments of both sexes of Switzerland?
Offer a very short reply. -2.50e+05. In the year 1987, what is the difference between the Number of enrolments of both sexes in Bahrain and Number of enrolments of both sexes in Central African Republic?
Keep it short and to the point. 5578. In the year 1987, what is the difference between the Number of enrolments of both sexes of Bahrain and Number of enrolments of both sexes of Malawi?
Give a very brief answer. 5850. In the year 1987, what is the difference between the Number of enrolments of both sexes in Bahrain and Number of enrolments of both sexes in Switzerland?
Offer a very short reply. -2.42e+05. In the year 1987, what is the difference between the Number of enrolments of both sexes in Central African Republic and Number of enrolments of both sexes in Malawi?
Ensure brevity in your answer.  272. In the year 1987, what is the difference between the Number of enrolments of both sexes of Central African Republic and Number of enrolments of both sexes of Switzerland?
Provide a short and direct response. -2.48e+05. In the year 1987, what is the difference between the Number of enrolments of both sexes in Malawi and Number of enrolments of both sexes in Switzerland?
Provide a short and direct response. -2.48e+05. In the year 1988, what is the difference between the Number of enrolments of both sexes of Bahrain and Number of enrolments of both sexes of Central African Republic?
Your response must be concise. 5286. In the year 1988, what is the difference between the Number of enrolments of both sexes of Bahrain and Number of enrolments of both sexes of Malawi?
Give a very brief answer. 4867. In the year 1988, what is the difference between the Number of enrolments of both sexes of Bahrain and Number of enrolments of both sexes of Switzerland?
Your answer should be compact. -2.41e+05. In the year 1988, what is the difference between the Number of enrolments of both sexes of Central African Republic and Number of enrolments of both sexes of Malawi?
Provide a short and direct response. -419. In the year 1988, what is the difference between the Number of enrolments of both sexes in Central African Republic and Number of enrolments of both sexes in Switzerland?
Give a very brief answer. -2.47e+05. In the year 1988, what is the difference between the Number of enrolments of both sexes of Malawi and Number of enrolments of both sexes of Switzerland?
Give a very brief answer. -2.46e+05. In the year 1989, what is the difference between the Number of enrolments of both sexes in Bahrain and Number of enrolments of both sexes in Central African Republic?
Ensure brevity in your answer.  4736. In the year 1989, what is the difference between the Number of enrolments of both sexes of Bahrain and Number of enrolments of both sexes of Malawi?
Make the answer very short. 4741. In the year 1989, what is the difference between the Number of enrolments of both sexes in Bahrain and Number of enrolments of both sexes in Switzerland?
Your response must be concise. -2.38e+05. In the year 1989, what is the difference between the Number of enrolments of both sexes of Central African Republic and Number of enrolments of both sexes of Malawi?
Your response must be concise. 5. In the year 1989, what is the difference between the Number of enrolments of both sexes in Central African Republic and Number of enrolments of both sexes in Switzerland?
Provide a short and direct response. -2.43e+05. In the year 1989, what is the difference between the Number of enrolments of both sexes in Malawi and Number of enrolments of both sexes in Switzerland?
Keep it short and to the point. -2.43e+05. In the year 1990, what is the difference between the Number of enrolments of both sexes in Bahrain and Number of enrolments of both sexes in Central African Republic?
Offer a terse response. 2898. In the year 1990, what is the difference between the Number of enrolments of both sexes in Bahrain and Number of enrolments of both sexes in Malawi?
Provide a short and direct response. 4236. In the year 1990, what is the difference between the Number of enrolments of both sexes of Bahrain and Number of enrolments of both sexes of Switzerland?
Your answer should be compact. -2.33e+05. In the year 1990, what is the difference between the Number of enrolments of both sexes in Central African Republic and Number of enrolments of both sexes in Malawi?
Your answer should be compact. 1338. In the year 1990, what is the difference between the Number of enrolments of both sexes in Central African Republic and Number of enrolments of both sexes in Switzerland?
Give a very brief answer. -2.36e+05. In the year 1990, what is the difference between the Number of enrolments of both sexes in Malawi and Number of enrolments of both sexes in Switzerland?
Offer a terse response. -2.37e+05. What is the ratio of the Number of enrolments of both sexes in Bahrain in 1983 to that in 1984?
Your answer should be very brief. 0.83. What is the ratio of the Number of enrolments of both sexes of Central African Republic in 1983 to that in 1984?
Give a very brief answer. 1.07. What is the ratio of the Number of enrolments of both sexes of Malawi in 1983 to that in 1984?
Provide a succinct answer. 1.07. What is the ratio of the Number of enrolments of both sexes of Switzerland in 1983 to that in 1984?
Keep it short and to the point. 0.98. What is the ratio of the Number of enrolments of both sexes in Bahrain in 1983 to that in 1985?
Offer a terse response. 0.76. What is the ratio of the Number of enrolments of both sexes of Central African Republic in 1983 to that in 1985?
Your answer should be very brief. 1.39. What is the ratio of the Number of enrolments of both sexes in Malawi in 1983 to that in 1985?
Your response must be concise. 1.09. What is the ratio of the Number of enrolments of both sexes of Switzerland in 1983 to that in 1985?
Offer a terse response. 0.97. What is the ratio of the Number of enrolments of both sexes of Bahrain in 1983 to that in 1986?
Make the answer very short. 0.74. What is the ratio of the Number of enrolments of both sexes in Central African Republic in 1983 to that in 1986?
Provide a short and direct response. 1.38. What is the ratio of the Number of enrolments of both sexes in Switzerland in 1983 to that in 1986?
Keep it short and to the point. 0.97. What is the ratio of the Number of enrolments of both sexes of Bahrain in 1983 to that in 1987?
Provide a succinct answer. 0.76. What is the ratio of the Number of enrolments of both sexes of Central African Republic in 1983 to that in 1987?
Your answer should be compact. 1.51. What is the ratio of the Number of enrolments of both sexes of Malawi in 1983 to that in 1987?
Give a very brief answer. 0.98. What is the ratio of the Number of enrolments of both sexes in Switzerland in 1983 to that in 1987?
Your response must be concise. 0.98. What is the ratio of the Number of enrolments of both sexes of Bahrain in 1983 to that in 1988?
Keep it short and to the point. 0.8. What is the ratio of the Number of enrolments of both sexes of Central African Republic in 1983 to that in 1988?
Make the answer very short. 1.6. What is the ratio of the Number of enrolments of both sexes of Malawi in 1983 to that in 1988?
Make the answer very short. 0.75. What is the ratio of the Number of enrolments of both sexes in Switzerland in 1983 to that in 1988?
Provide a succinct answer. 0.99. What is the ratio of the Number of enrolments of both sexes of Bahrain in 1983 to that in 1989?
Your answer should be compact. 0.87. What is the ratio of the Number of enrolments of both sexes in Central African Republic in 1983 to that in 1989?
Keep it short and to the point. 1.62. What is the ratio of the Number of enrolments of both sexes of Malawi in 1983 to that in 1989?
Offer a very short reply. 0.91. What is the ratio of the Number of enrolments of both sexes of Switzerland in 1983 to that in 1989?
Provide a short and direct response. 1. What is the ratio of the Number of enrolments of both sexes in Bahrain in 1983 to that in 1990?
Keep it short and to the point. 0.91. What is the ratio of the Number of enrolments of both sexes of Central African Republic in 1983 to that in 1990?
Offer a very short reply. 0.91. What is the ratio of the Number of enrolments of both sexes in Malawi in 1983 to that in 1990?
Provide a succinct answer. 0.83. What is the ratio of the Number of enrolments of both sexes in Switzerland in 1983 to that in 1990?
Provide a short and direct response. 1.03. What is the ratio of the Number of enrolments of both sexes in Bahrain in 1984 to that in 1985?
Your answer should be very brief. 0.92. What is the ratio of the Number of enrolments of both sexes in Central African Republic in 1984 to that in 1985?
Your answer should be very brief. 1.29. What is the ratio of the Number of enrolments of both sexes of Malawi in 1984 to that in 1985?
Provide a short and direct response. 1.01. What is the ratio of the Number of enrolments of both sexes of Switzerland in 1984 to that in 1985?
Provide a succinct answer. 0.99. What is the ratio of the Number of enrolments of both sexes of Bahrain in 1984 to that in 1986?
Offer a very short reply. 0.9. What is the ratio of the Number of enrolments of both sexes of Central African Republic in 1984 to that in 1986?
Offer a terse response. 1.28. What is the ratio of the Number of enrolments of both sexes of Malawi in 1984 to that in 1986?
Offer a terse response. 0.93. What is the ratio of the Number of enrolments of both sexes of Switzerland in 1984 to that in 1986?
Offer a terse response. 1. What is the ratio of the Number of enrolments of both sexes of Bahrain in 1984 to that in 1987?
Offer a very short reply. 0.92. What is the ratio of the Number of enrolments of both sexes in Central African Republic in 1984 to that in 1987?
Provide a succinct answer. 1.4. What is the ratio of the Number of enrolments of both sexes in Malawi in 1984 to that in 1987?
Offer a very short reply. 0.91. What is the ratio of the Number of enrolments of both sexes in Bahrain in 1984 to that in 1988?
Keep it short and to the point. 0.97. What is the ratio of the Number of enrolments of both sexes in Central African Republic in 1984 to that in 1988?
Your response must be concise. 1.49. What is the ratio of the Number of enrolments of both sexes of Malawi in 1984 to that in 1988?
Offer a terse response. 0.7. What is the ratio of the Number of enrolments of both sexes of Switzerland in 1984 to that in 1988?
Your answer should be very brief. 1.01. What is the ratio of the Number of enrolments of both sexes of Bahrain in 1984 to that in 1989?
Your response must be concise. 1.05. What is the ratio of the Number of enrolments of both sexes in Central African Republic in 1984 to that in 1989?
Make the answer very short. 1.5. What is the ratio of the Number of enrolments of both sexes of Malawi in 1984 to that in 1989?
Offer a terse response. 0.85. What is the ratio of the Number of enrolments of both sexes of Switzerland in 1984 to that in 1989?
Make the answer very short. 1.03. What is the ratio of the Number of enrolments of both sexes in Bahrain in 1984 to that in 1990?
Offer a very short reply. 1.1. What is the ratio of the Number of enrolments of both sexes in Central African Republic in 1984 to that in 1990?
Give a very brief answer. 0.85. What is the ratio of the Number of enrolments of both sexes in Malawi in 1984 to that in 1990?
Offer a very short reply. 0.78. What is the ratio of the Number of enrolments of both sexes of Switzerland in 1984 to that in 1990?
Give a very brief answer. 1.05. What is the ratio of the Number of enrolments of both sexes of Bahrain in 1985 to that in 1986?
Offer a very short reply. 0.97. What is the ratio of the Number of enrolments of both sexes in Central African Republic in 1985 to that in 1986?
Keep it short and to the point. 0.99. What is the ratio of the Number of enrolments of both sexes in Malawi in 1985 to that in 1986?
Offer a very short reply. 0.92. What is the ratio of the Number of enrolments of both sexes of Switzerland in 1985 to that in 1986?
Offer a terse response. 1.01. What is the ratio of the Number of enrolments of both sexes of Bahrain in 1985 to that in 1987?
Offer a terse response. 0.99. What is the ratio of the Number of enrolments of both sexes of Central African Republic in 1985 to that in 1987?
Keep it short and to the point. 1.09. What is the ratio of the Number of enrolments of both sexes in Malawi in 1985 to that in 1987?
Your answer should be compact. 0.9. What is the ratio of the Number of enrolments of both sexes in Switzerland in 1985 to that in 1987?
Provide a succinct answer. 1.01. What is the ratio of the Number of enrolments of both sexes in Bahrain in 1985 to that in 1988?
Your response must be concise. 1.05. What is the ratio of the Number of enrolments of both sexes in Central African Republic in 1985 to that in 1988?
Make the answer very short. 1.15. What is the ratio of the Number of enrolments of both sexes in Malawi in 1985 to that in 1988?
Ensure brevity in your answer.  0.69. What is the ratio of the Number of enrolments of both sexes of Switzerland in 1985 to that in 1988?
Give a very brief answer. 1.02. What is the ratio of the Number of enrolments of both sexes of Bahrain in 1985 to that in 1989?
Your response must be concise. 1.14. What is the ratio of the Number of enrolments of both sexes of Central African Republic in 1985 to that in 1989?
Provide a short and direct response. 1.16. What is the ratio of the Number of enrolments of both sexes of Malawi in 1985 to that in 1989?
Your answer should be compact. 0.84. What is the ratio of the Number of enrolments of both sexes in Switzerland in 1985 to that in 1989?
Your answer should be very brief. 1.04. What is the ratio of the Number of enrolments of both sexes in Bahrain in 1985 to that in 1990?
Make the answer very short. 1.19. What is the ratio of the Number of enrolments of both sexes in Central African Republic in 1985 to that in 1990?
Ensure brevity in your answer.  0.66. What is the ratio of the Number of enrolments of both sexes in Malawi in 1985 to that in 1990?
Your answer should be compact. 0.77. What is the ratio of the Number of enrolments of both sexes in Switzerland in 1985 to that in 1990?
Offer a very short reply. 1.06. What is the ratio of the Number of enrolments of both sexes of Bahrain in 1986 to that in 1987?
Keep it short and to the point. 1.02. What is the ratio of the Number of enrolments of both sexes of Central African Republic in 1986 to that in 1987?
Your response must be concise. 1.09. What is the ratio of the Number of enrolments of both sexes in Malawi in 1986 to that in 1987?
Offer a very short reply. 0.98. What is the ratio of the Number of enrolments of both sexes of Switzerland in 1986 to that in 1987?
Give a very brief answer. 1.01. What is the ratio of the Number of enrolments of both sexes of Bahrain in 1986 to that in 1988?
Offer a very short reply. 1.08. What is the ratio of the Number of enrolments of both sexes in Central African Republic in 1986 to that in 1988?
Your answer should be compact. 1.16. What is the ratio of the Number of enrolments of both sexes of Malawi in 1986 to that in 1988?
Make the answer very short. 0.75. What is the ratio of the Number of enrolments of both sexes of Switzerland in 1986 to that in 1988?
Offer a very short reply. 1.01. What is the ratio of the Number of enrolments of both sexes in Bahrain in 1986 to that in 1989?
Your answer should be compact. 1.17. What is the ratio of the Number of enrolments of both sexes of Central African Republic in 1986 to that in 1989?
Offer a very short reply. 1.17. What is the ratio of the Number of enrolments of both sexes in Malawi in 1986 to that in 1989?
Make the answer very short. 0.92. What is the ratio of the Number of enrolments of both sexes in Switzerland in 1986 to that in 1989?
Provide a short and direct response. 1.03. What is the ratio of the Number of enrolments of both sexes of Bahrain in 1986 to that in 1990?
Give a very brief answer. 1.23. What is the ratio of the Number of enrolments of both sexes of Central African Republic in 1986 to that in 1990?
Ensure brevity in your answer.  0.66. What is the ratio of the Number of enrolments of both sexes of Malawi in 1986 to that in 1990?
Offer a terse response. 0.84. What is the ratio of the Number of enrolments of both sexes of Switzerland in 1986 to that in 1990?
Make the answer very short. 1.06. What is the ratio of the Number of enrolments of both sexes in Bahrain in 1987 to that in 1988?
Your response must be concise. 1.06. What is the ratio of the Number of enrolments of both sexes in Central African Republic in 1987 to that in 1988?
Offer a terse response. 1.06. What is the ratio of the Number of enrolments of both sexes of Malawi in 1987 to that in 1988?
Keep it short and to the point. 0.77. What is the ratio of the Number of enrolments of both sexes of Switzerland in 1987 to that in 1988?
Offer a terse response. 1.01. What is the ratio of the Number of enrolments of both sexes in Bahrain in 1987 to that in 1989?
Make the answer very short. 1.15. What is the ratio of the Number of enrolments of both sexes of Central African Republic in 1987 to that in 1989?
Provide a succinct answer. 1.07. What is the ratio of the Number of enrolments of both sexes in Switzerland in 1987 to that in 1989?
Your answer should be very brief. 1.02. What is the ratio of the Number of enrolments of both sexes in Bahrain in 1987 to that in 1990?
Provide a short and direct response. 1.2. What is the ratio of the Number of enrolments of both sexes of Central African Republic in 1987 to that in 1990?
Provide a short and direct response. 0.61. What is the ratio of the Number of enrolments of both sexes in Malawi in 1987 to that in 1990?
Provide a short and direct response. 0.85. What is the ratio of the Number of enrolments of both sexes in Switzerland in 1987 to that in 1990?
Ensure brevity in your answer.  1.05. What is the ratio of the Number of enrolments of both sexes of Bahrain in 1988 to that in 1989?
Make the answer very short. 1.08. What is the ratio of the Number of enrolments of both sexes in Central African Republic in 1988 to that in 1989?
Keep it short and to the point. 1.01. What is the ratio of the Number of enrolments of both sexes in Malawi in 1988 to that in 1989?
Make the answer very short. 1.22. What is the ratio of the Number of enrolments of both sexes of Switzerland in 1988 to that in 1989?
Keep it short and to the point. 1.02. What is the ratio of the Number of enrolments of both sexes in Bahrain in 1988 to that in 1990?
Ensure brevity in your answer.  1.14. What is the ratio of the Number of enrolments of both sexes in Malawi in 1988 to that in 1990?
Give a very brief answer. 1.12. What is the ratio of the Number of enrolments of both sexes in Switzerland in 1988 to that in 1990?
Offer a very short reply. 1.04. What is the ratio of the Number of enrolments of both sexes in Bahrain in 1989 to that in 1990?
Make the answer very short. 1.05. What is the ratio of the Number of enrolments of both sexes in Central African Republic in 1989 to that in 1990?
Offer a very short reply. 0.57. What is the ratio of the Number of enrolments of both sexes of Malawi in 1989 to that in 1990?
Make the answer very short. 0.91. What is the ratio of the Number of enrolments of both sexes of Switzerland in 1989 to that in 1990?
Make the answer very short. 1.02. What is the difference between the highest and the second highest Number of enrolments of both sexes in Bahrain?
Your answer should be very brief. 160. What is the difference between the highest and the second highest Number of enrolments of both sexes in Central African Republic?
Provide a short and direct response. 301. What is the difference between the highest and the second highest Number of enrolments of both sexes in Malawi?
Your response must be concise. 251. What is the difference between the highest and the second highest Number of enrolments of both sexes of Switzerland?
Your response must be concise. 1420. What is the difference between the highest and the lowest Number of enrolments of both sexes of Bahrain?
Give a very brief answer. 2026. What is the difference between the highest and the lowest Number of enrolments of both sexes of Central African Republic?
Give a very brief answer. 1525. What is the difference between the highest and the lowest Number of enrolments of both sexes in Malawi?
Give a very brief answer. 758. What is the difference between the highest and the lowest Number of enrolments of both sexes of Switzerland?
Your answer should be compact. 1.46e+04. 